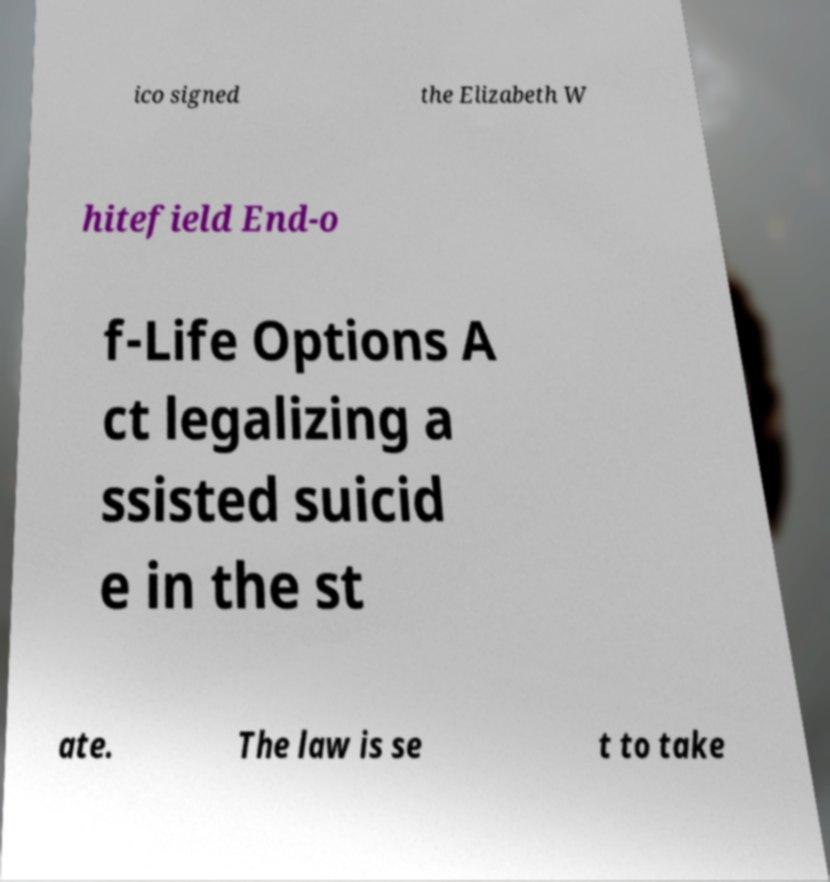For documentation purposes, I need the text within this image transcribed. Could you provide that? ico signed the Elizabeth W hitefield End-o f-Life Options A ct legalizing a ssisted suicid e in the st ate. The law is se t to take 